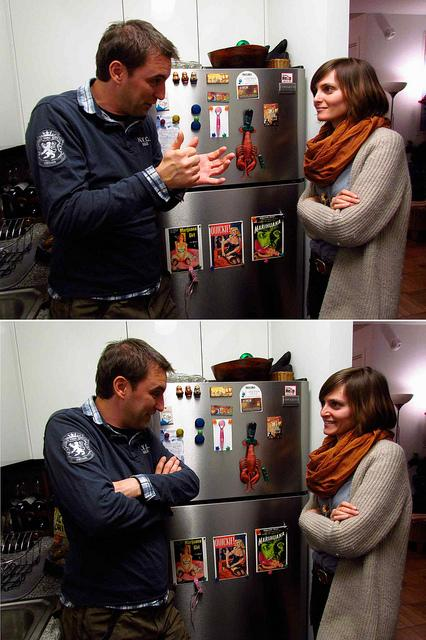How did the women feel about the man's remark?

Choices:
A) bored
B) amused
C) offended
D) embarrassed amused 